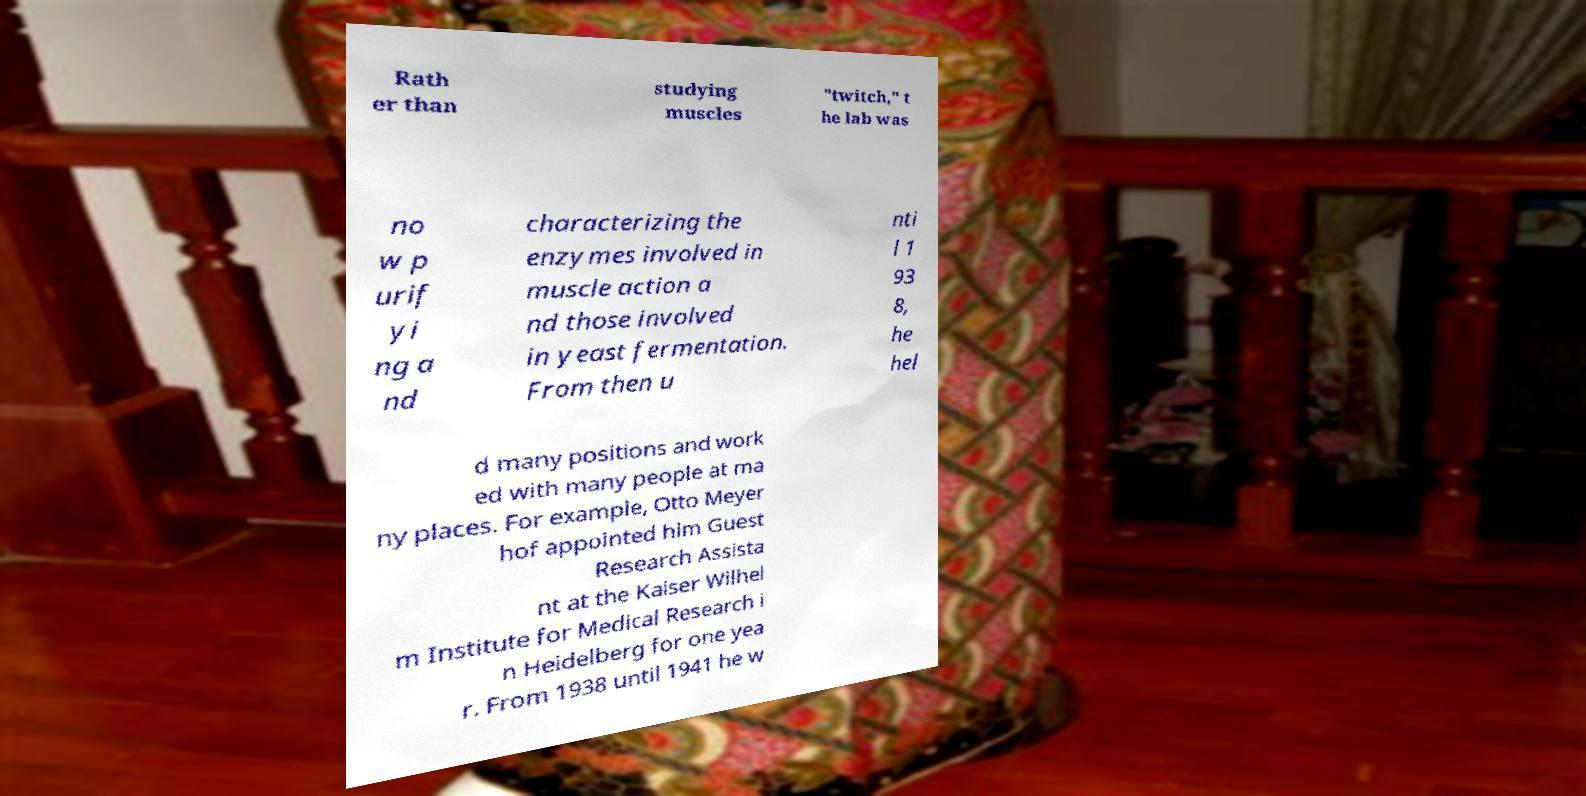Please identify and transcribe the text found in this image. Rath er than studying muscles "twitch," t he lab was no w p urif yi ng a nd characterizing the enzymes involved in muscle action a nd those involved in yeast fermentation. From then u nti l 1 93 8, he hel d many positions and work ed with many people at ma ny places. For example, Otto Meyer hof appointed him Guest Research Assista nt at the Kaiser Wilhel m Institute for Medical Research i n Heidelberg for one yea r. From 1938 until 1941 he w 